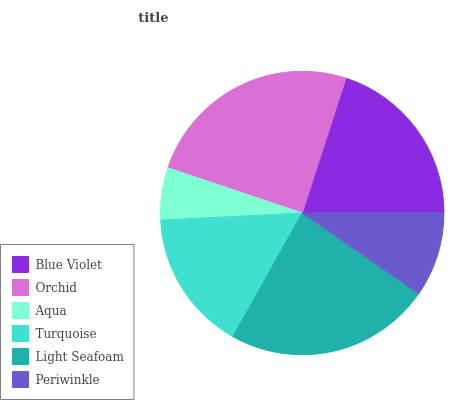Is Aqua the minimum?
Answer yes or no. Yes. Is Orchid the maximum?
Answer yes or no. Yes. Is Orchid the minimum?
Answer yes or no. No. Is Aqua the maximum?
Answer yes or no. No. Is Orchid greater than Aqua?
Answer yes or no. Yes. Is Aqua less than Orchid?
Answer yes or no. Yes. Is Aqua greater than Orchid?
Answer yes or no. No. Is Orchid less than Aqua?
Answer yes or no. No. Is Blue Violet the high median?
Answer yes or no. Yes. Is Turquoise the low median?
Answer yes or no. Yes. Is Aqua the high median?
Answer yes or no. No. Is Orchid the low median?
Answer yes or no. No. 